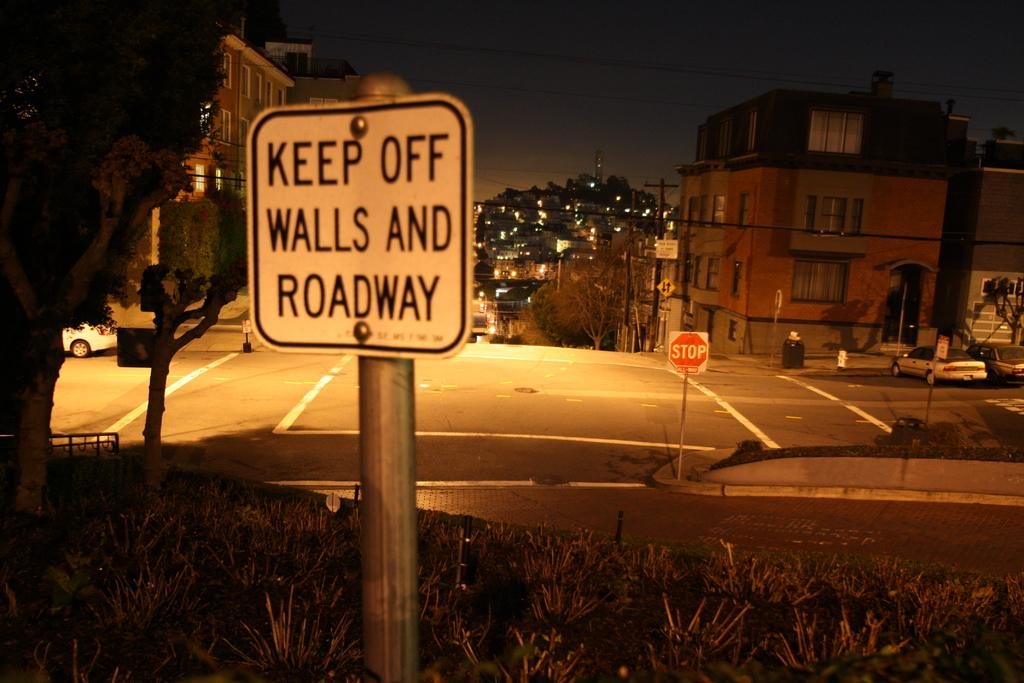<image>
Provide a brief description of the given image. A sign warns people to keep off the walls and roadway. 